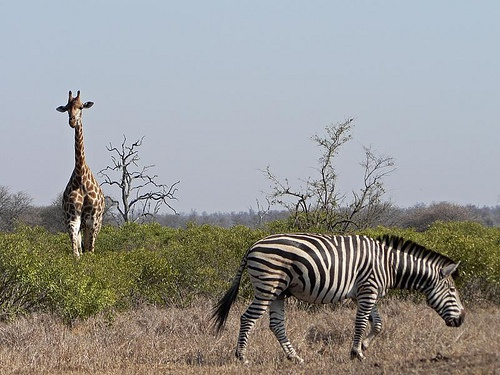Describe the objects in this image and their specific colors. I can see zebra in lightblue, black, gray, darkgray, and ivory tones and giraffe in lightblue, black, gray, ivory, and maroon tones in this image. 